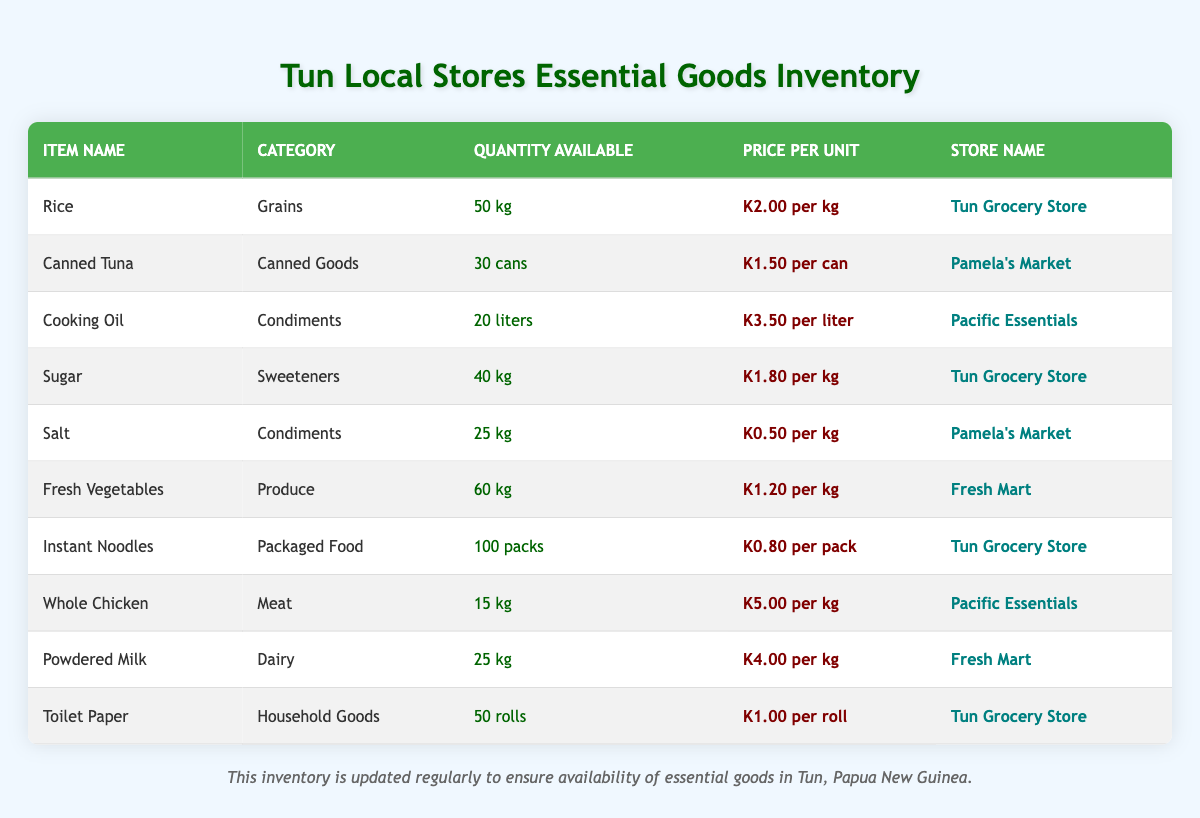What is the quantity available of Rice in the Tun Grocery Store? The table lists the inventory of goods. To find Rice, I look for the row where the item name is "Rice." I see that the quantity available is 50 kg.
Answer: 50 kg Which store sells Canned Tuna? I refer to the row for Canned Tuna in the table. The store associated with Canned Tuna is Pamela's Market.
Answer: Pamela's Market What is the total quantity of Condiments available? I locate all items in the "Condiments" category, which are Cooking Oil and Salt. Their quantities are 20 liters and 25 kg, respectively. I convert liters to kg for consistency if needed (but in this case, we keep them separate). So, the total quantity available is 20 + 25 = 45.
Answer: 45 (20 liters + 25 kg) Is Sugar more expensive than Salt? I compare the price per unit of Sugar (K1.80 per kg) and Salt (K0.50 per kg). Since K1.80 is greater than K0.50, the statement is true.
Answer: Yes How many more packs of Instant Noodles are available compared to Whole Chicken? I check the quantities: Instant Noodles have 100 packs, while Whole Chicken has 15 kg. To find the difference, I subtract: 100 - 15 = 85.
Answer: 85 packs What is the price per unit of Powdered Milk, and is it higher than that of Sugar? I find Powdered Milk priced at K4.00 per kg and Sugar at K1.80 per kg. Comparing the two prices shows that K4.00 is indeed higher than K1.80.
Answer: Yes Which store has the largest quantity of Fresh Vegetables? Fresh Mart sells Fresh Vegetables. The quantity available is 60 kg. I look for this specific entry in the table to confirm it has the highest quantity compared to other stores for similar products.
Answer: Fresh Mart What is the average price per unit of the household goods listed in the table? The household goods listed are Toilet Paper, Canned Tuna, and Salt. Their prices are K1.00, K1.50, and K0.50, respectively. To find the average, I first sum these prices: K1.00 + K1.50 + K0.50 = K3.00. Then, I divide this by 3 (the number of items), which gives K3.00 / 3 = K1.00.
Answer: K1.00 